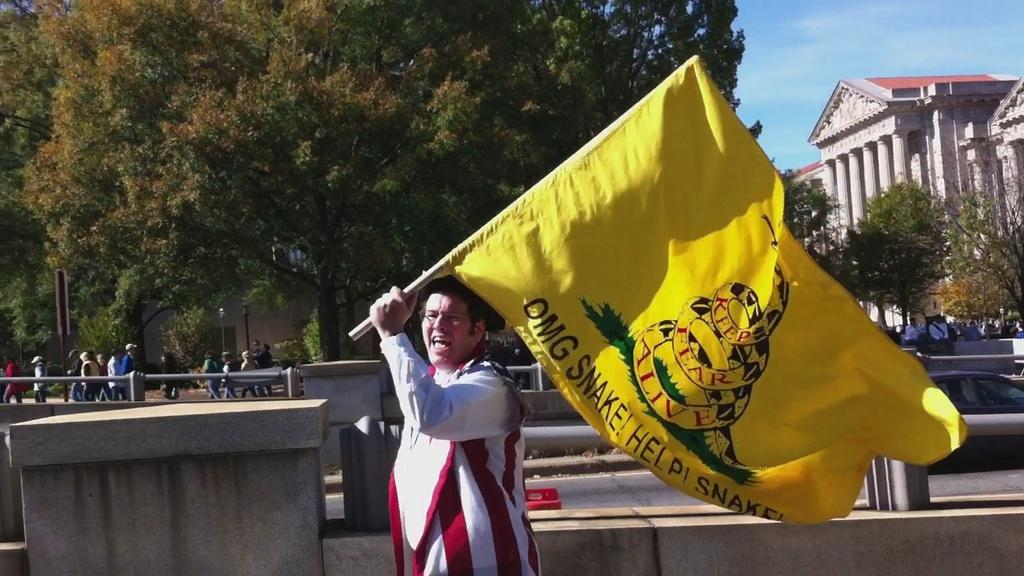<image>
Render a clear and concise summary of the photo. the word snake is on the yellow flag 